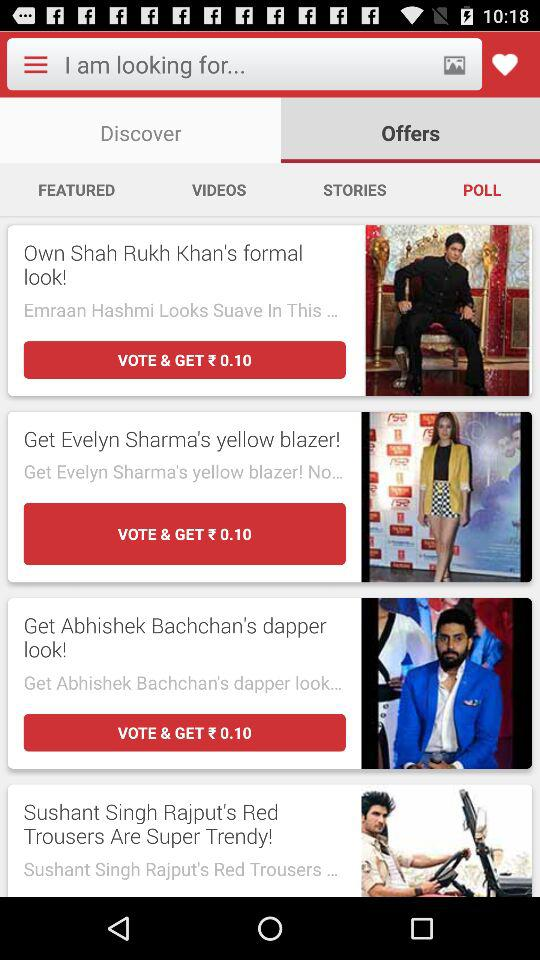Which tab is selected? The selected tab is "Offers". 